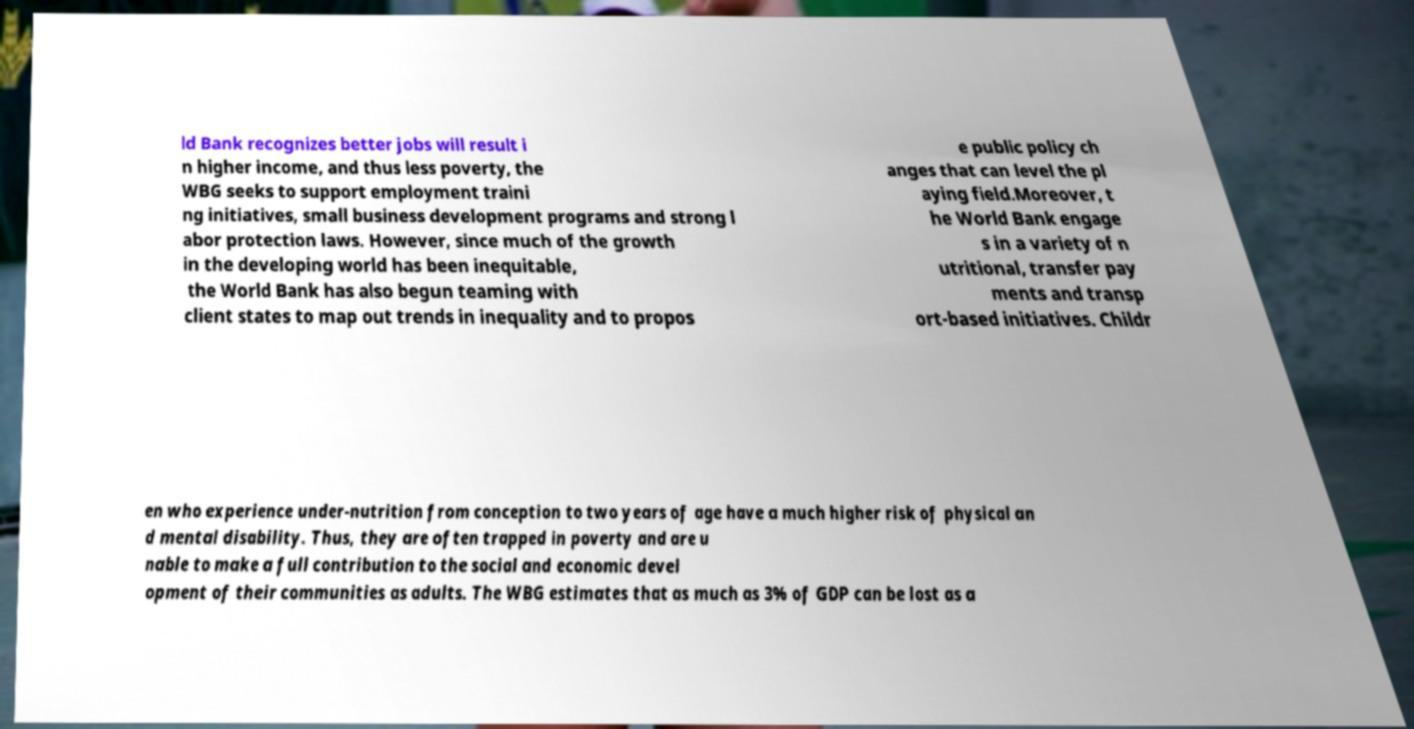Could you assist in decoding the text presented in this image and type it out clearly? ld Bank recognizes better jobs will result i n higher income, and thus less poverty, the WBG seeks to support employment traini ng initiatives, small business development programs and strong l abor protection laws. However, since much of the growth in the developing world has been inequitable, the World Bank has also begun teaming with client states to map out trends in inequality and to propos e public policy ch anges that can level the pl aying field.Moreover, t he World Bank engage s in a variety of n utritional, transfer pay ments and transp ort-based initiatives. Childr en who experience under-nutrition from conception to two years of age have a much higher risk of physical an d mental disability. Thus, they are often trapped in poverty and are u nable to make a full contribution to the social and economic devel opment of their communities as adults. The WBG estimates that as much as 3% of GDP can be lost as a 